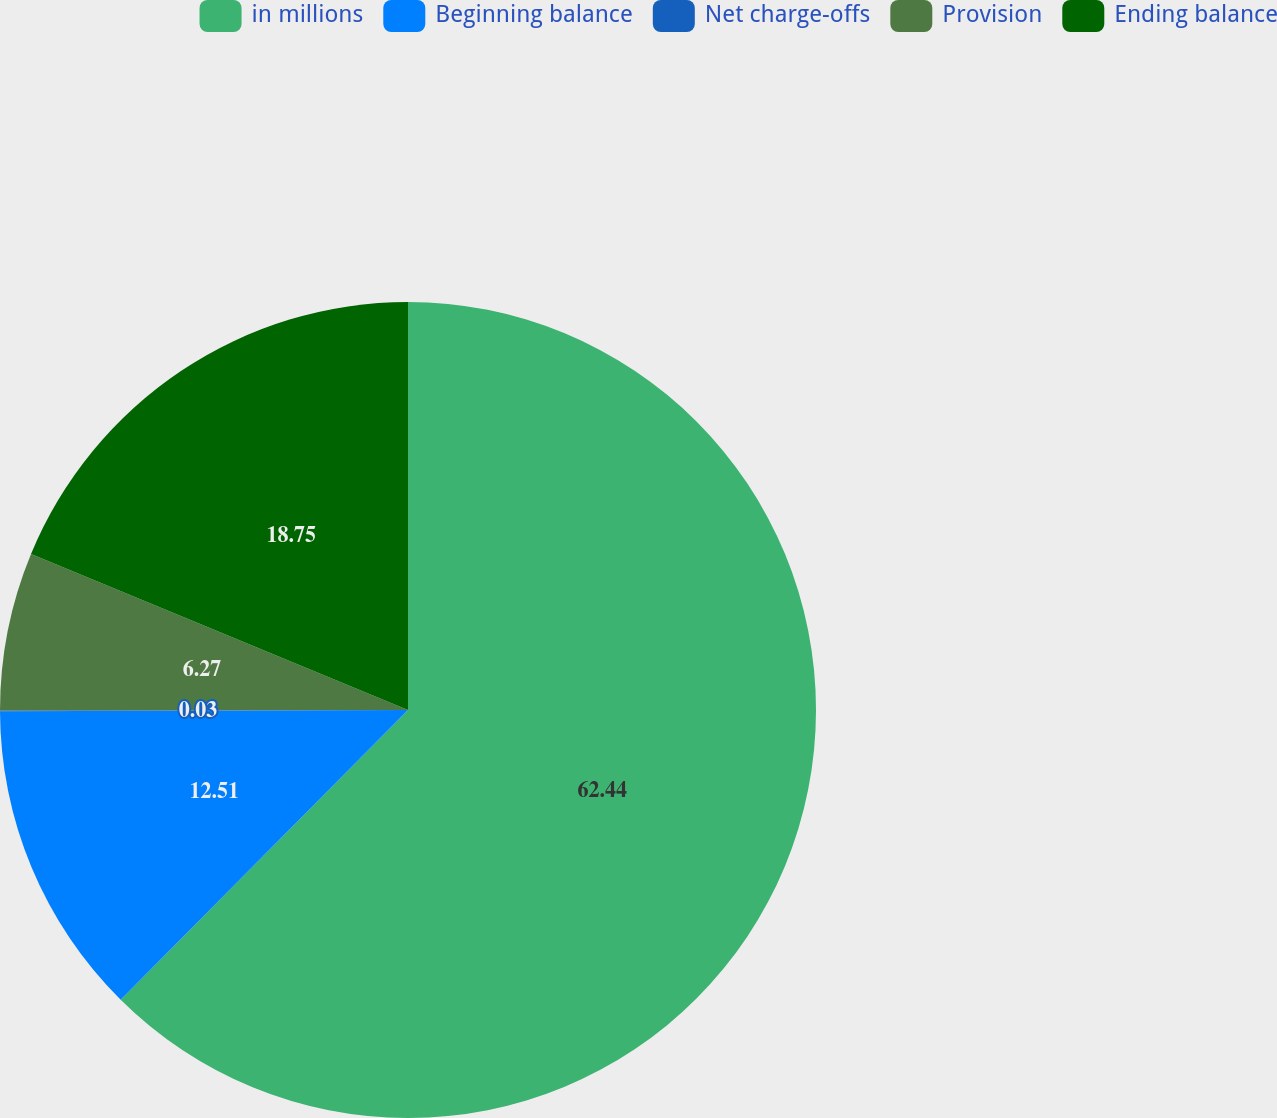Convert chart. <chart><loc_0><loc_0><loc_500><loc_500><pie_chart><fcel>in millions<fcel>Beginning balance<fcel>Net charge-offs<fcel>Provision<fcel>Ending balance<nl><fcel>62.43%<fcel>12.51%<fcel>0.03%<fcel>6.27%<fcel>18.75%<nl></chart> 